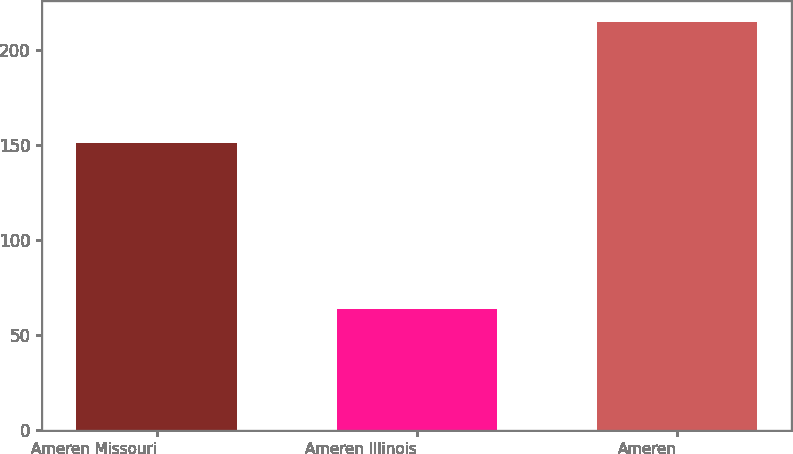<chart> <loc_0><loc_0><loc_500><loc_500><bar_chart><fcel>Ameren Missouri<fcel>Ameren Illinois<fcel>Ameren<nl><fcel>151<fcel>64<fcel>215<nl></chart> 